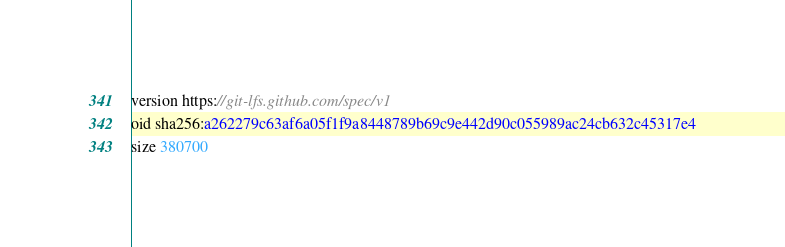Convert code to text. <code><loc_0><loc_0><loc_500><loc_500><_TypeScript_>version https://git-lfs.github.com/spec/v1
oid sha256:a262279c63af6a05f1f9a8448789b69c9e442d90c055989ac24cb632c45317e4
size 380700
</code> 